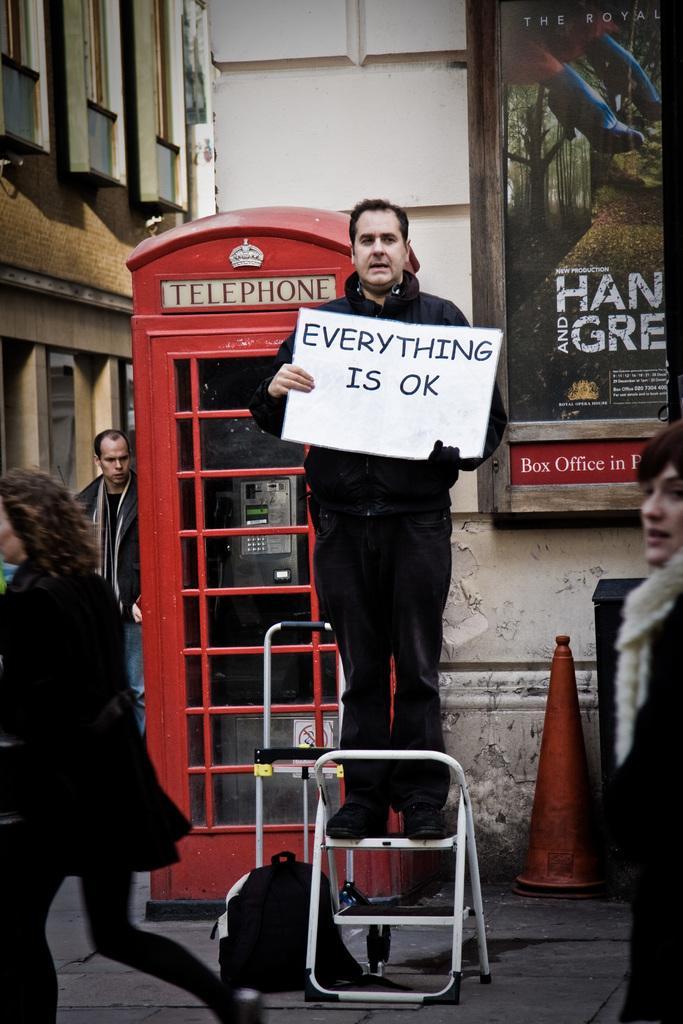Could you give a brief overview of what you see in this image? In this picture we can see four persons, a man in the middle is standing and holding a board, in the background there is a building, we can see a telephone booth in the middle, we can see a hoarding on the right side, there is a traffic cone and a bag at the bottom. 